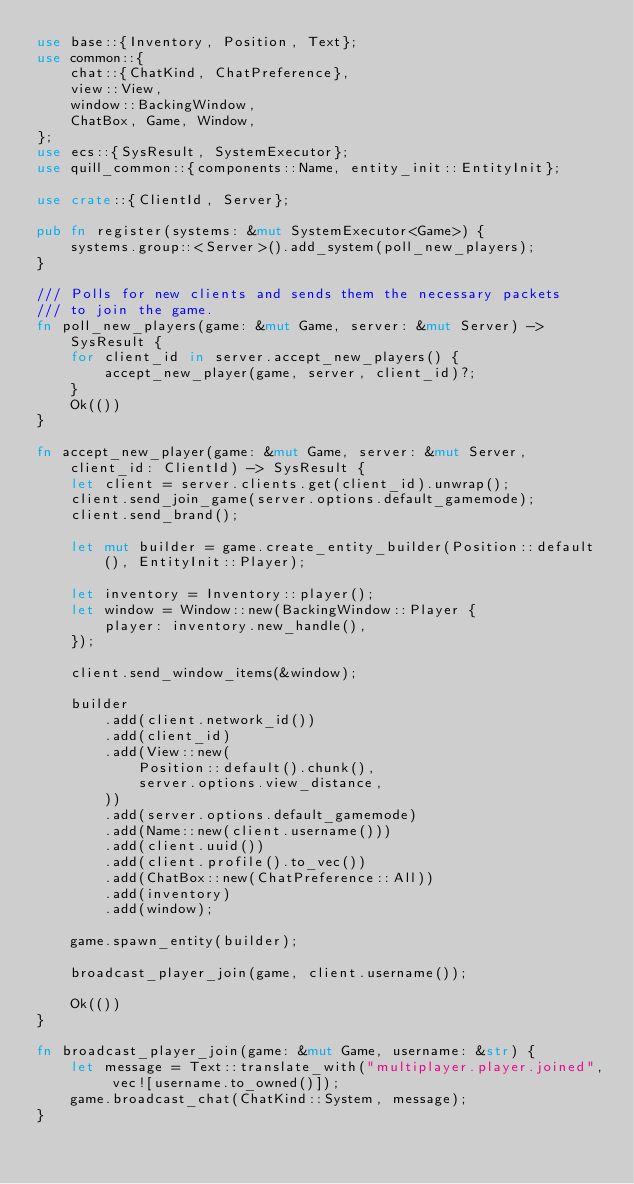Convert code to text. <code><loc_0><loc_0><loc_500><loc_500><_Rust_>use base::{Inventory, Position, Text};
use common::{
    chat::{ChatKind, ChatPreference},
    view::View,
    window::BackingWindow,
    ChatBox, Game, Window,
};
use ecs::{SysResult, SystemExecutor};
use quill_common::{components::Name, entity_init::EntityInit};

use crate::{ClientId, Server};

pub fn register(systems: &mut SystemExecutor<Game>) {
    systems.group::<Server>().add_system(poll_new_players);
}

/// Polls for new clients and sends them the necessary packets
/// to join the game.
fn poll_new_players(game: &mut Game, server: &mut Server) -> SysResult {
    for client_id in server.accept_new_players() {
        accept_new_player(game, server, client_id)?;
    }
    Ok(())
}

fn accept_new_player(game: &mut Game, server: &mut Server, client_id: ClientId) -> SysResult {
    let client = server.clients.get(client_id).unwrap();
    client.send_join_game(server.options.default_gamemode);
    client.send_brand();

    let mut builder = game.create_entity_builder(Position::default(), EntityInit::Player);

    let inventory = Inventory::player();
    let window = Window::new(BackingWindow::Player {
        player: inventory.new_handle(),
    });

    client.send_window_items(&window);

    builder
        .add(client.network_id())
        .add(client_id)
        .add(View::new(
            Position::default().chunk(),
            server.options.view_distance,
        ))
        .add(server.options.default_gamemode)
        .add(Name::new(client.username()))
        .add(client.uuid())
        .add(client.profile().to_vec())
        .add(ChatBox::new(ChatPreference::All))
        .add(inventory)
        .add(window);

    game.spawn_entity(builder);

    broadcast_player_join(game, client.username());

    Ok(())
}

fn broadcast_player_join(game: &mut Game, username: &str) {
    let message = Text::translate_with("multiplayer.player.joined", vec![username.to_owned()]);
    game.broadcast_chat(ChatKind::System, message);
}
</code> 